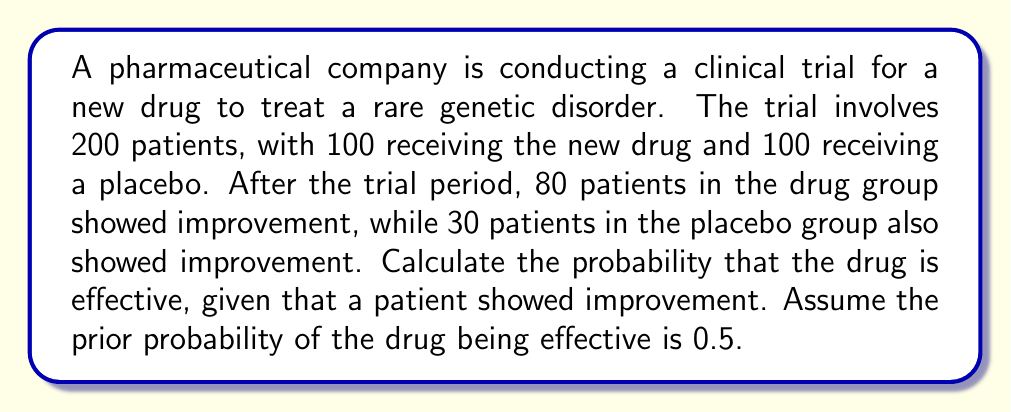Give your solution to this math problem. To solve this problem, we'll use Bayes' theorem. Let's define our events:

A: The drug is effective
B: A patient showed improvement

We need to calculate P(A|B), which is the probability that the drug is effective given that a patient showed improvement.

Bayes' theorem states:

$$ P(A|B) = \frac{P(B|A) \cdot P(A)}{P(B)} $$

Let's calculate each component:

1. P(A) = 0.5 (given prior probability)

2. P(B|A) = 80/100 = 0.8 (probability of improvement given the drug is effective)

3. P(B) = P(B|A) * P(A) + P(B|not A) * P(not A)
   = (80/100 * 0.5) + (30/100 * 0.5)
   = 0.4 + 0.15
   = 0.55

Now, let's substitute these values into Bayes' theorem:

$$ P(A|B) = \frac{0.8 \cdot 0.5}{0.55} $$

$$ P(A|B) = \frac{0.4}{0.55} $$

$$ P(A|B) \approx 0.7273 $$

Therefore, the probability that the drug is effective, given that a patient showed improvement, is approximately 0.7273 or 72.73%.
Answer: 0.7273 (or 72.73%) 